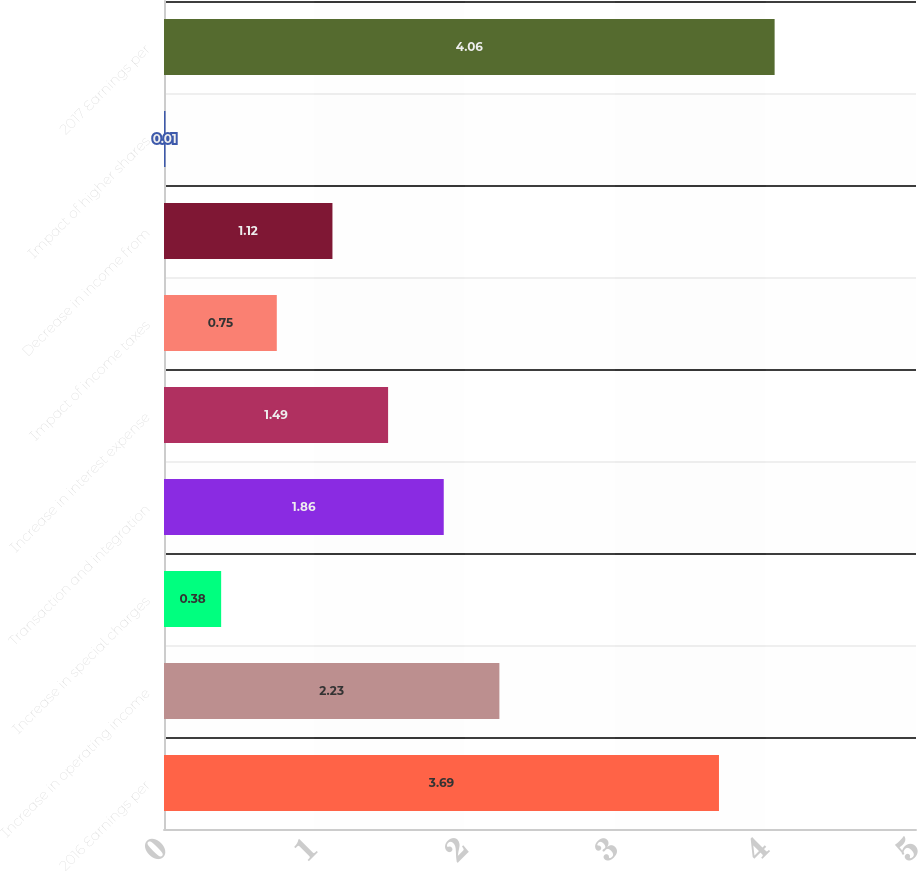<chart> <loc_0><loc_0><loc_500><loc_500><bar_chart><fcel>2016 Earnings per<fcel>Increase in operating income<fcel>Increase in special charges<fcel>Transaction and integration<fcel>Increase in interest expense<fcel>Impact of income taxes<fcel>Decrease in income from<fcel>Impact of higher shares<fcel>2017 Earnings per<nl><fcel>3.69<fcel>2.23<fcel>0.38<fcel>1.86<fcel>1.49<fcel>0.75<fcel>1.12<fcel>0.01<fcel>4.06<nl></chart> 